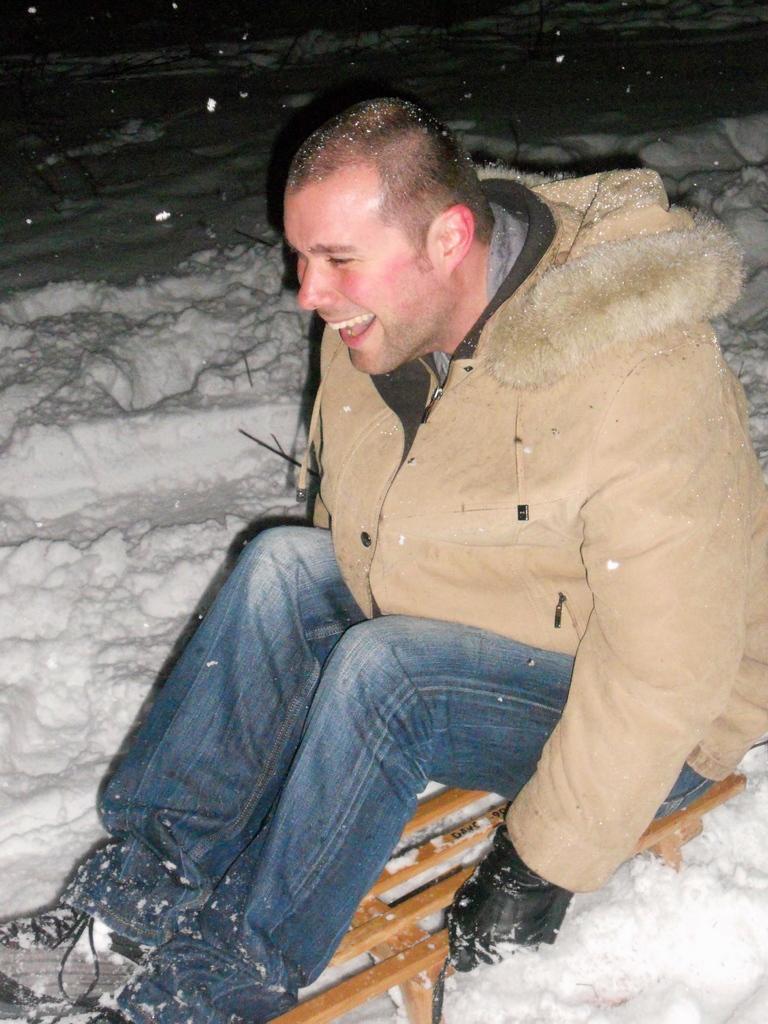Can you describe this image briefly? In this image I can see the person is sitting on the brown color object. I can see the snow. 